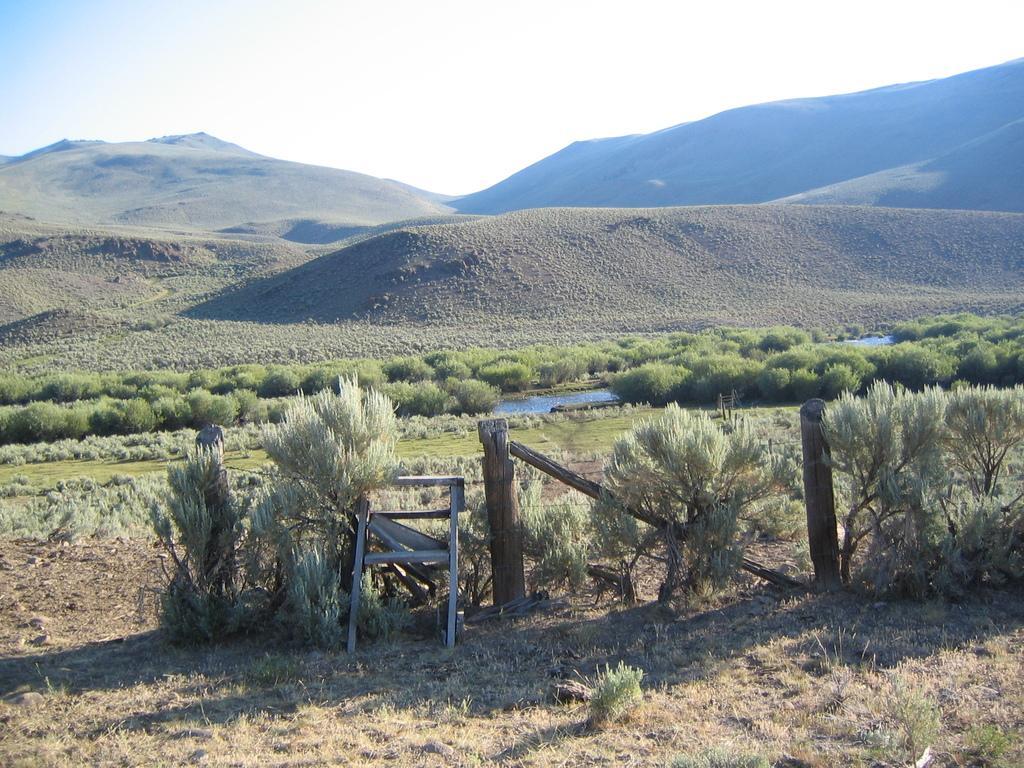How would you summarize this image in a sentence or two? In this picture we can see plants, grass, object and wooden fence. In the background of the image we can see plants, water, hills and sky. 